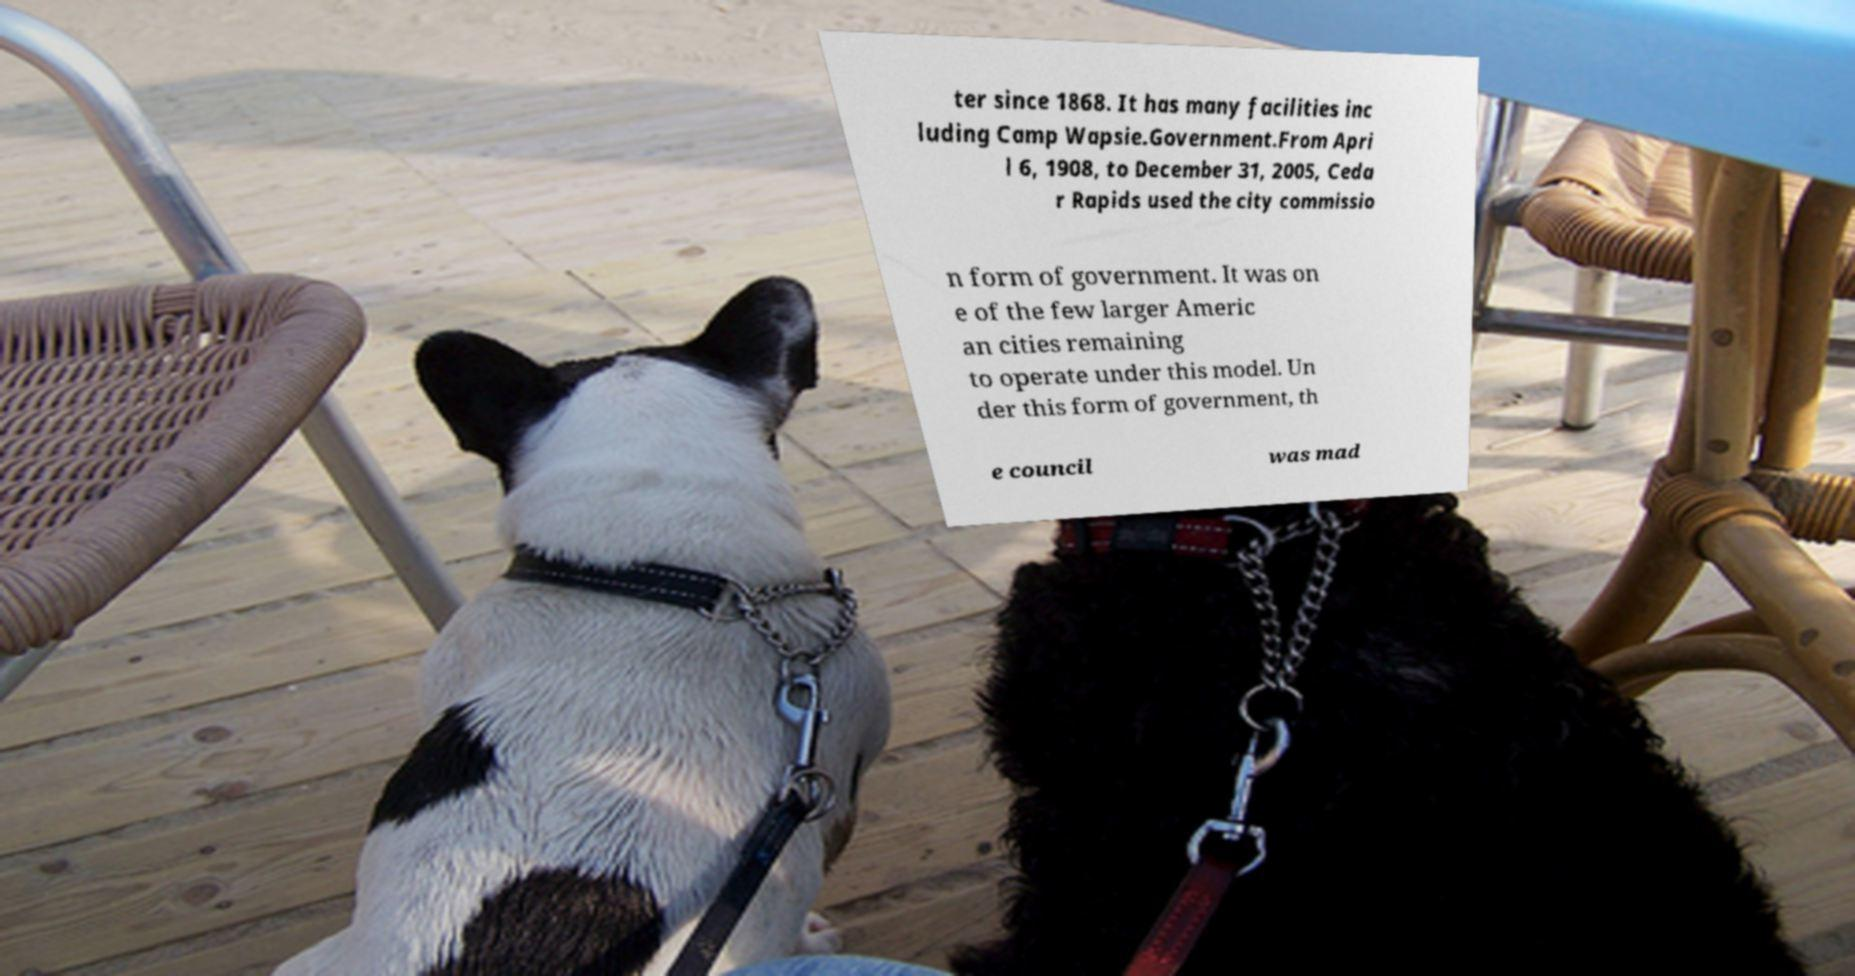Could you extract and type out the text from this image? ter since 1868. It has many facilities inc luding Camp Wapsie.Government.From Apri l 6, 1908, to December 31, 2005, Ceda r Rapids used the city commissio n form of government. It was on e of the few larger Americ an cities remaining to operate under this model. Un der this form of government, th e council was mad 